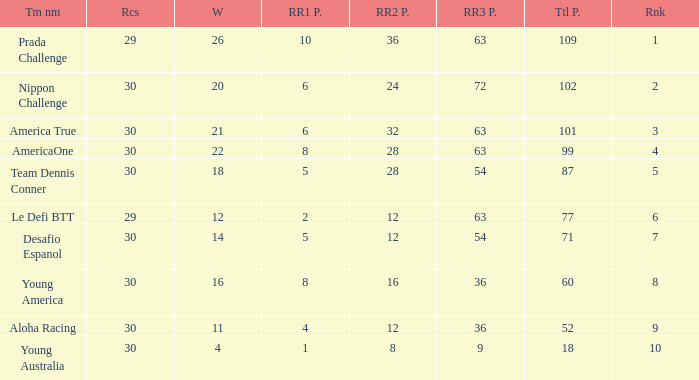Name the min total pts for team dennis conner 87.0. 